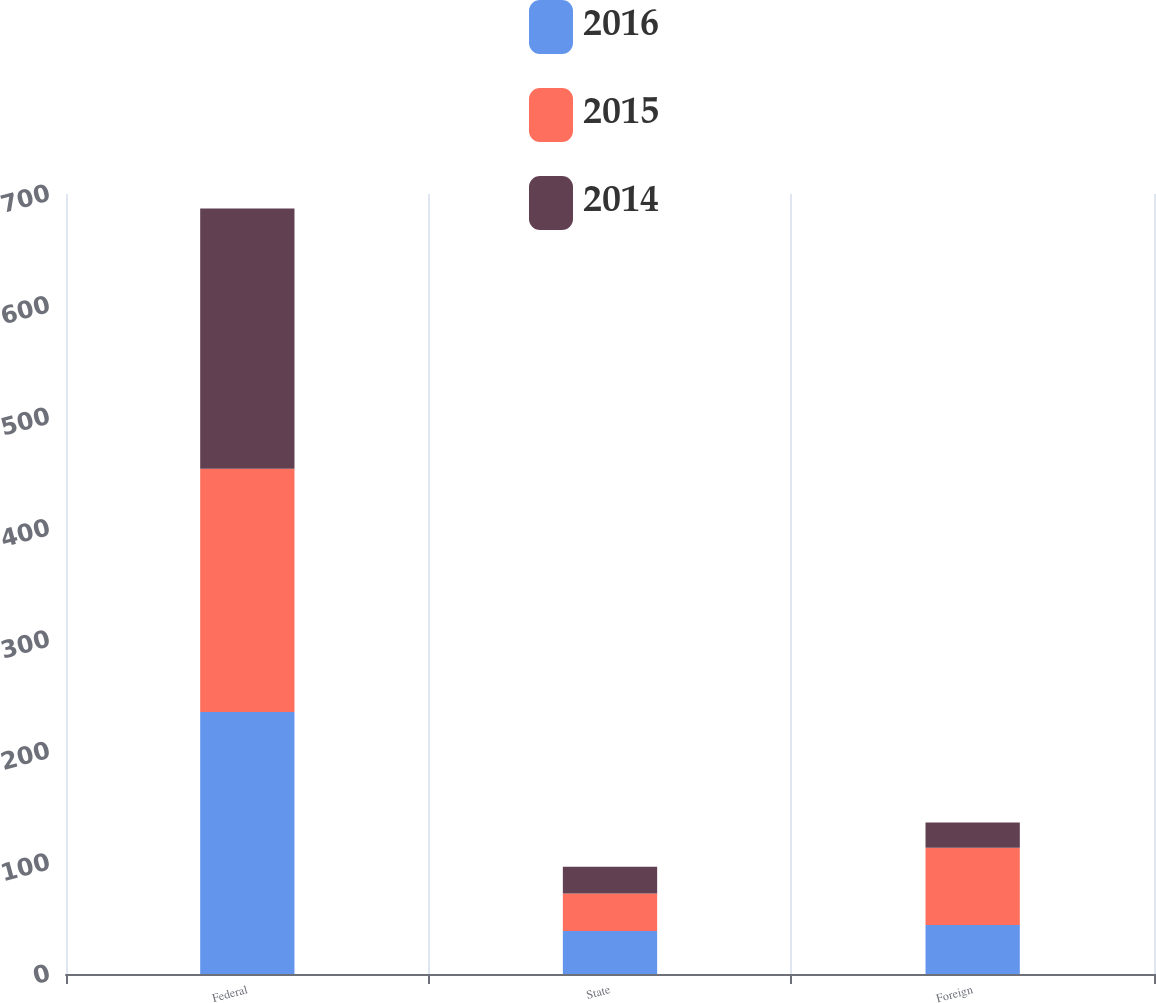Convert chart. <chart><loc_0><loc_0><loc_500><loc_500><stacked_bar_chart><ecel><fcel>Federal<fcel>State<fcel>Foreign<nl><fcel>2016<fcel>235.1<fcel>38.6<fcel>43.9<nl><fcel>2015<fcel>218.3<fcel>33.7<fcel>69.4<nl><fcel>2014<fcel>233.6<fcel>24<fcel>22.7<nl></chart> 